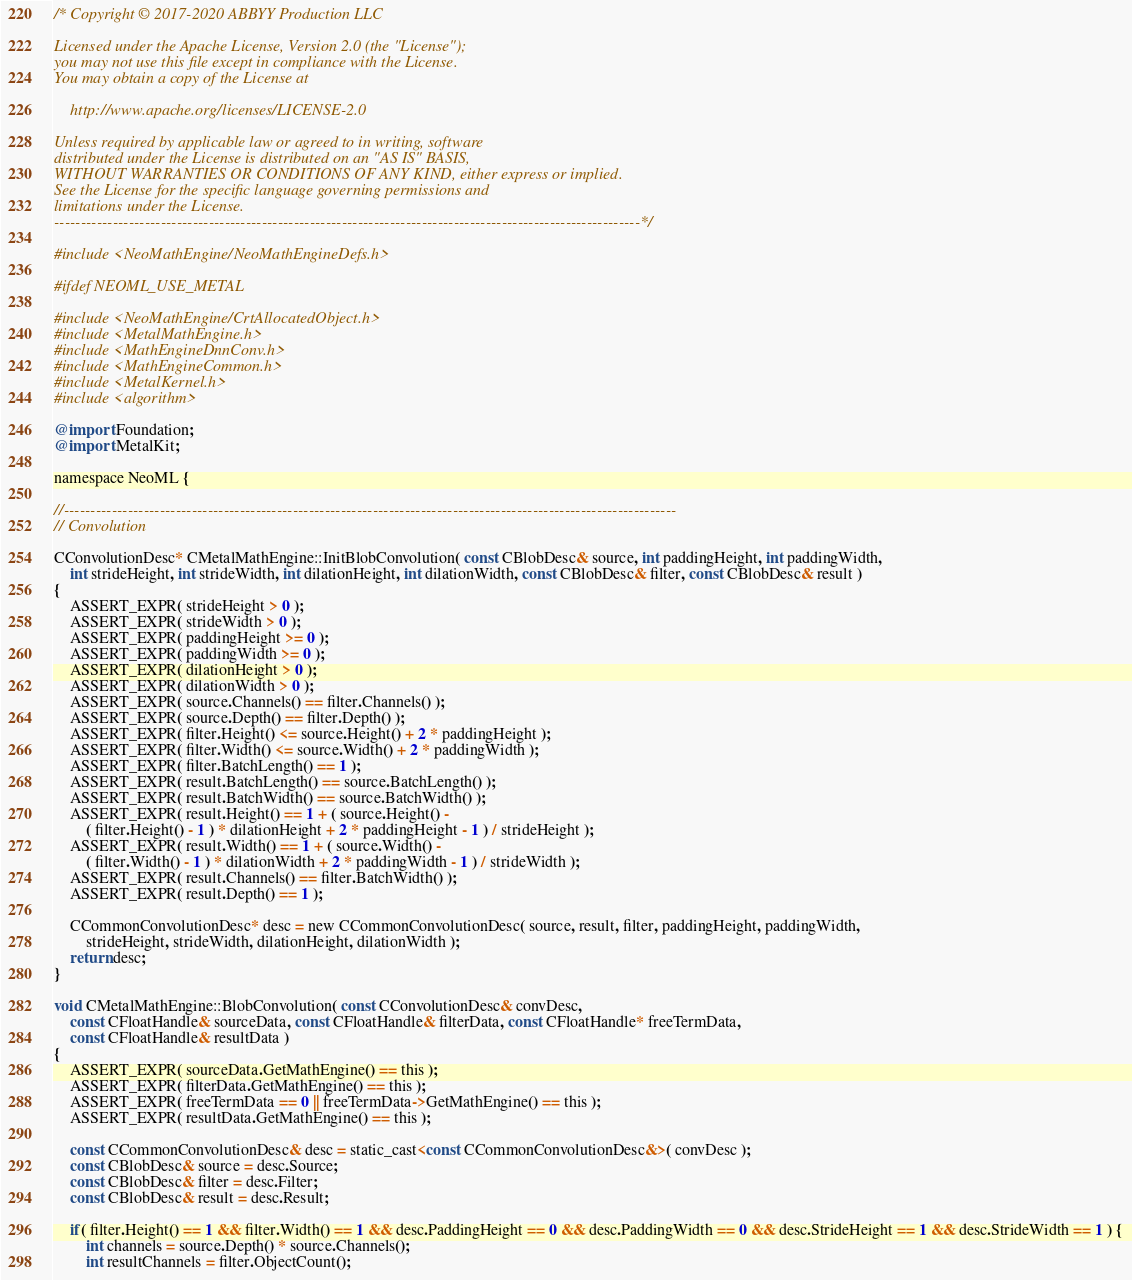Convert code to text. <code><loc_0><loc_0><loc_500><loc_500><_ObjectiveC_>/* Copyright © 2017-2020 ABBYY Production LLC

Licensed under the Apache License, Version 2.0 (the "License");
you may not use this file except in compliance with the License.
You may obtain a copy of the License at

	http://www.apache.org/licenses/LICENSE-2.0

Unless required by applicable law or agreed to in writing, software
distributed under the License is distributed on an "AS IS" BASIS,
WITHOUT WARRANTIES OR CONDITIONS OF ANY KIND, either express or implied.
See the License for the specific language governing permissions and
limitations under the License.
--------------------------------------------------------------------------------------------------------------*/

#include <NeoMathEngine/NeoMathEngineDefs.h>

#ifdef NEOML_USE_METAL

#include <NeoMathEngine/CrtAllocatedObject.h>
#include <MetalMathEngine.h>
#include <MathEngineDnnConv.h>
#include <MathEngineCommon.h>
#include <MetalKernel.h>
#include <algorithm>

@import Foundation;
@import MetalKit;

namespace NeoML {

//-------------------------------------------------------------------------------------------------------------------
// Convolution

CConvolutionDesc* CMetalMathEngine::InitBlobConvolution( const CBlobDesc& source, int paddingHeight, int paddingWidth,
	int strideHeight, int strideWidth, int dilationHeight, int dilationWidth, const CBlobDesc& filter, const CBlobDesc& result )
{
	ASSERT_EXPR( strideHeight > 0 );
	ASSERT_EXPR( strideWidth > 0 );
	ASSERT_EXPR( paddingHeight >= 0 );
	ASSERT_EXPR( paddingWidth >= 0 );
	ASSERT_EXPR( dilationHeight > 0 );
	ASSERT_EXPR( dilationWidth > 0 );
	ASSERT_EXPR( source.Channels() == filter.Channels() );
	ASSERT_EXPR( source.Depth() == filter.Depth() );
	ASSERT_EXPR( filter.Height() <= source.Height() + 2 * paddingHeight );
	ASSERT_EXPR( filter.Width() <= source.Width() + 2 * paddingWidth );
	ASSERT_EXPR( filter.BatchLength() == 1 );
	ASSERT_EXPR( result.BatchLength() == source.BatchLength() );
	ASSERT_EXPR( result.BatchWidth() == source.BatchWidth() );
	ASSERT_EXPR( result.Height() == 1 + ( source.Height() -
		( filter.Height() - 1 ) * dilationHeight + 2 * paddingHeight - 1 ) / strideHeight );
	ASSERT_EXPR( result.Width() == 1 + ( source.Width() -
		( filter.Width() - 1 ) * dilationWidth + 2 * paddingWidth - 1 ) / strideWidth );
	ASSERT_EXPR( result.Channels() == filter.BatchWidth() );
	ASSERT_EXPR( result.Depth() == 1 );

	CCommonConvolutionDesc* desc = new CCommonConvolutionDesc( source, result, filter, paddingHeight, paddingWidth,
		strideHeight, strideWidth, dilationHeight, dilationWidth );
	return desc;
}

void CMetalMathEngine::BlobConvolution( const CConvolutionDesc& convDesc,
	const CFloatHandle& sourceData, const CFloatHandle& filterData, const CFloatHandle* freeTermData,
	const CFloatHandle& resultData )
{
	ASSERT_EXPR( sourceData.GetMathEngine() == this );
	ASSERT_EXPR( filterData.GetMathEngine() == this );
	ASSERT_EXPR( freeTermData == 0 || freeTermData->GetMathEngine() == this );
	ASSERT_EXPR( resultData.GetMathEngine() == this );

	const CCommonConvolutionDesc& desc = static_cast<const CCommonConvolutionDesc&>( convDesc );
	const CBlobDesc& source = desc.Source;
	const CBlobDesc& filter = desc.Filter;
	const CBlobDesc& result = desc.Result;

    if( filter.Height() == 1 && filter.Width() == 1 && desc.PaddingHeight == 0 && desc.PaddingWidth == 0 && desc.StrideHeight == 1 && desc.StrideWidth == 1 ) {
        int channels = source.Depth() * source.Channels();
        int resultChannels = filter.ObjectCount();
</code> 